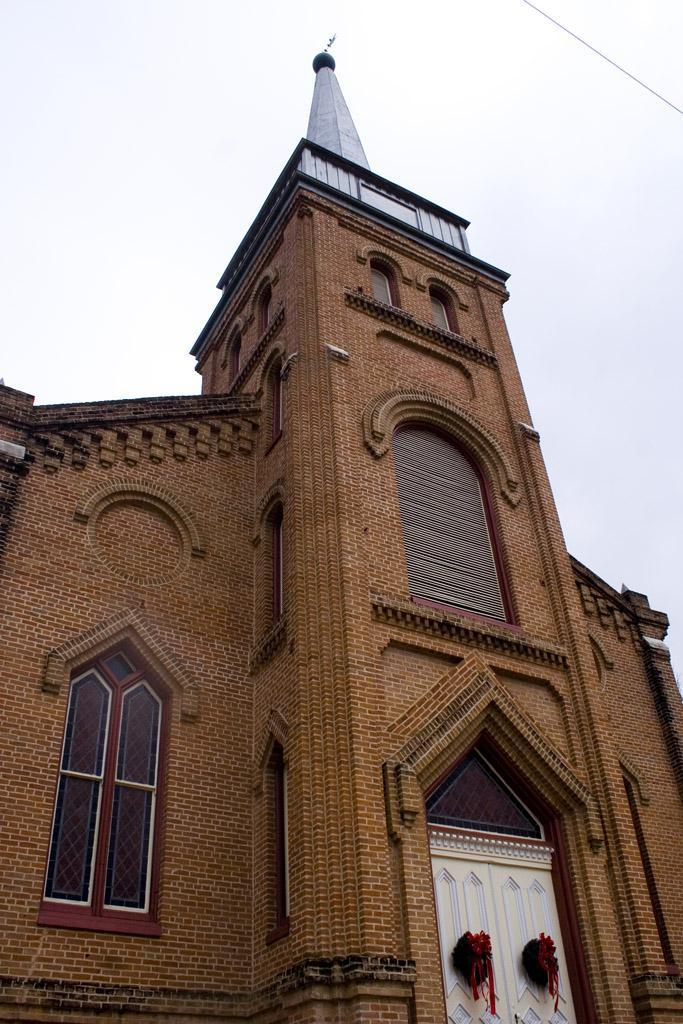What can be seen in the background of the image? The sky is visible in the image. What is the wire truncated towards the left of the image? There is a wire truncated towards the left of the image. What type of building is truncated in the image? There is a church truncated in the image. What architectural feature is present in the image? There are windows in the image. What is on the door in the image? There are objects on the door in the image. Can you see a plant growing on the church in the image? There is no plant growing on the church in the image. Is there a pencil visible in the image? There is no pencil present in the image. 